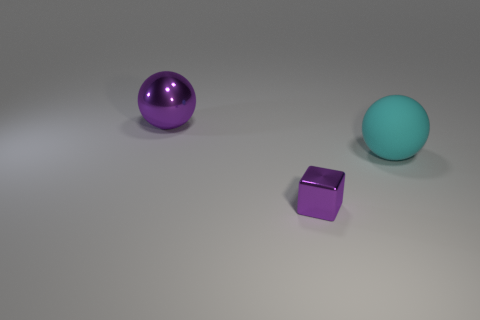Add 2 cyan spheres. How many objects exist? 5 Subtract all cubes. How many objects are left? 2 Subtract 0 green blocks. How many objects are left? 3 Subtract all big purple metallic things. Subtract all matte objects. How many objects are left? 1 Add 1 cyan matte things. How many cyan matte things are left? 2 Add 1 small yellow things. How many small yellow things exist? 1 